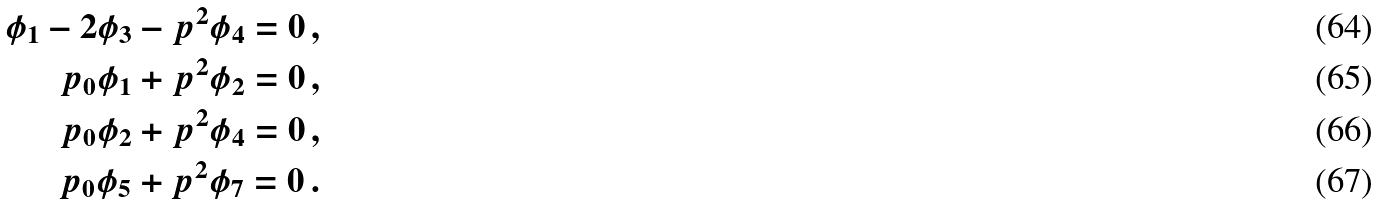Convert formula to latex. <formula><loc_0><loc_0><loc_500><loc_500>\phi _ { 1 } - 2 \phi _ { 3 } - { p } ^ { 2 } \phi _ { 4 } = 0 \, , \\ p _ { 0 } \phi _ { 1 } + { p } ^ { 2 } \phi _ { 2 } = 0 \, , \\ p _ { 0 } \phi _ { 2 } + { p } ^ { 2 } \phi _ { 4 } = 0 \, , \\ p _ { 0 } \phi _ { 5 } + { p } ^ { 2 } \phi _ { 7 } = 0 \, .</formula> 